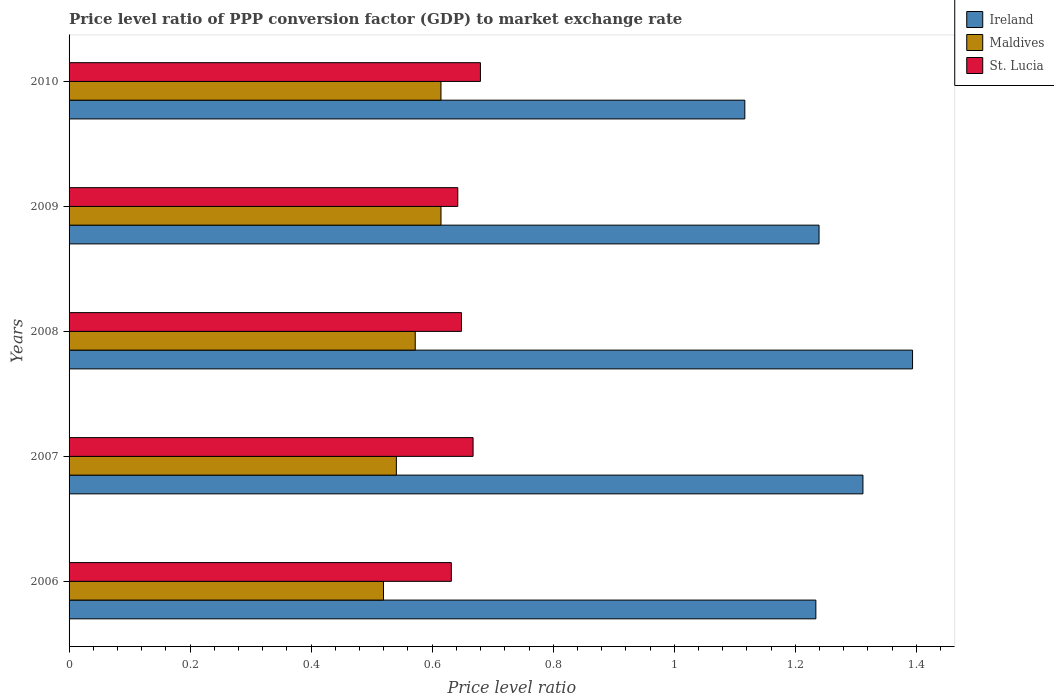How many groups of bars are there?
Provide a succinct answer. 5. Are the number of bars per tick equal to the number of legend labels?
Keep it short and to the point. Yes. How many bars are there on the 4th tick from the bottom?
Provide a short and direct response. 3. What is the label of the 2nd group of bars from the top?
Keep it short and to the point. 2009. In how many cases, is the number of bars for a given year not equal to the number of legend labels?
Your answer should be very brief. 0. What is the price level ratio in Maldives in 2007?
Provide a short and direct response. 0.54. Across all years, what is the maximum price level ratio in St. Lucia?
Give a very brief answer. 0.68. Across all years, what is the minimum price level ratio in Maldives?
Provide a succinct answer. 0.52. In which year was the price level ratio in St. Lucia minimum?
Offer a terse response. 2006. What is the total price level ratio in St. Lucia in the graph?
Ensure brevity in your answer.  3.27. What is the difference between the price level ratio in Ireland in 2006 and that in 2010?
Your answer should be compact. 0.12. What is the difference between the price level ratio in Ireland in 2009 and the price level ratio in St. Lucia in 2007?
Offer a terse response. 0.57. What is the average price level ratio in St. Lucia per year?
Your response must be concise. 0.65. In the year 2010, what is the difference between the price level ratio in Ireland and price level ratio in Maldives?
Your response must be concise. 0.5. What is the ratio of the price level ratio in Maldives in 2006 to that in 2007?
Keep it short and to the point. 0.96. Is the price level ratio in Maldives in 2007 less than that in 2008?
Offer a very short reply. Yes. What is the difference between the highest and the second highest price level ratio in Maldives?
Provide a succinct answer. 3.58968718040531e-5. What is the difference between the highest and the lowest price level ratio in Ireland?
Your answer should be very brief. 0.28. What does the 2nd bar from the top in 2007 represents?
Ensure brevity in your answer.  Maldives. What does the 2nd bar from the bottom in 2008 represents?
Offer a terse response. Maldives. Is it the case that in every year, the sum of the price level ratio in Ireland and price level ratio in St. Lucia is greater than the price level ratio in Maldives?
Your answer should be very brief. Yes. How many bars are there?
Provide a short and direct response. 15. Are all the bars in the graph horizontal?
Ensure brevity in your answer.  Yes. Does the graph contain any zero values?
Provide a succinct answer. No. Where does the legend appear in the graph?
Provide a short and direct response. Top right. How many legend labels are there?
Provide a succinct answer. 3. How are the legend labels stacked?
Provide a succinct answer. Vertical. What is the title of the graph?
Your answer should be very brief. Price level ratio of PPP conversion factor (GDP) to market exchange rate. Does "Fragile and conflict affected situations" appear as one of the legend labels in the graph?
Keep it short and to the point. No. What is the label or title of the X-axis?
Ensure brevity in your answer.  Price level ratio. What is the Price level ratio of Ireland in 2006?
Your answer should be compact. 1.23. What is the Price level ratio of Maldives in 2006?
Offer a very short reply. 0.52. What is the Price level ratio in St. Lucia in 2006?
Keep it short and to the point. 0.63. What is the Price level ratio in Ireland in 2007?
Offer a very short reply. 1.31. What is the Price level ratio in Maldives in 2007?
Give a very brief answer. 0.54. What is the Price level ratio in St. Lucia in 2007?
Make the answer very short. 0.67. What is the Price level ratio in Ireland in 2008?
Provide a succinct answer. 1.39. What is the Price level ratio of Maldives in 2008?
Offer a terse response. 0.57. What is the Price level ratio in St. Lucia in 2008?
Your response must be concise. 0.65. What is the Price level ratio of Ireland in 2009?
Your response must be concise. 1.24. What is the Price level ratio in Maldives in 2009?
Ensure brevity in your answer.  0.61. What is the Price level ratio in St. Lucia in 2009?
Your answer should be very brief. 0.64. What is the Price level ratio in Ireland in 2010?
Offer a terse response. 1.12. What is the Price level ratio in Maldives in 2010?
Provide a succinct answer. 0.61. What is the Price level ratio in St. Lucia in 2010?
Offer a terse response. 0.68. Across all years, what is the maximum Price level ratio of Ireland?
Your response must be concise. 1.39. Across all years, what is the maximum Price level ratio in Maldives?
Keep it short and to the point. 0.61. Across all years, what is the maximum Price level ratio of St. Lucia?
Keep it short and to the point. 0.68. Across all years, what is the minimum Price level ratio in Ireland?
Your answer should be very brief. 1.12. Across all years, what is the minimum Price level ratio in Maldives?
Your answer should be very brief. 0.52. Across all years, what is the minimum Price level ratio in St. Lucia?
Make the answer very short. 0.63. What is the total Price level ratio in Ireland in the graph?
Your answer should be very brief. 6.3. What is the total Price level ratio in Maldives in the graph?
Your answer should be very brief. 2.86. What is the total Price level ratio of St. Lucia in the graph?
Your answer should be very brief. 3.27. What is the difference between the Price level ratio in Ireland in 2006 and that in 2007?
Your answer should be very brief. -0.08. What is the difference between the Price level ratio of Maldives in 2006 and that in 2007?
Your answer should be very brief. -0.02. What is the difference between the Price level ratio of St. Lucia in 2006 and that in 2007?
Provide a short and direct response. -0.04. What is the difference between the Price level ratio in Ireland in 2006 and that in 2008?
Ensure brevity in your answer.  -0.16. What is the difference between the Price level ratio in Maldives in 2006 and that in 2008?
Give a very brief answer. -0.05. What is the difference between the Price level ratio of St. Lucia in 2006 and that in 2008?
Give a very brief answer. -0.02. What is the difference between the Price level ratio in Ireland in 2006 and that in 2009?
Offer a very short reply. -0.01. What is the difference between the Price level ratio of Maldives in 2006 and that in 2009?
Offer a very short reply. -0.1. What is the difference between the Price level ratio in St. Lucia in 2006 and that in 2009?
Provide a short and direct response. -0.01. What is the difference between the Price level ratio in Ireland in 2006 and that in 2010?
Offer a terse response. 0.12. What is the difference between the Price level ratio of Maldives in 2006 and that in 2010?
Offer a terse response. -0.1. What is the difference between the Price level ratio in St. Lucia in 2006 and that in 2010?
Make the answer very short. -0.05. What is the difference between the Price level ratio in Ireland in 2007 and that in 2008?
Offer a terse response. -0.08. What is the difference between the Price level ratio in Maldives in 2007 and that in 2008?
Your answer should be very brief. -0.03. What is the difference between the Price level ratio in St. Lucia in 2007 and that in 2008?
Your answer should be very brief. 0.02. What is the difference between the Price level ratio in Ireland in 2007 and that in 2009?
Give a very brief answer. 0.07. What is the difference between the Price level ratio in Maldives in 2007 and that in 2009?
Provide a short and direct response. -0.07. What is the difference between the Price level ratio of St. Lucia in 2007 and that in 2009?
Keep it short and to the point. 0.03. What is the difference between the Price level ratio of Ireland in 2007 and that in 2010?
Provide a succinct answer. 0.2. What is the difference between the Price level ratio in Maldives in 2007 and that in 2010?
Give a very brief answer. -0.07. What is the difference between the Price level ratio in St. Lucia in 2007 and that in 2010?
Provide a short and direct response. -0.01. What is the difference between the Price level ratio in Ireland in 2008 and that in 2009?
Your response must be concise. 0.15. What is the difference between the Price level ratio in Maldives in 2008 and that in 2009?
Give a very brief answer. -0.04. What is the difference between the Price level ratio in St. Lucia in 2008 and that in 2009?
Your response must be concise. 0.01. What is the difference between the Price level ratio of Ireland in 2008 and that in 2010?
Provide a succinct answer. 0.28. What is the difference between the Price level ratio in Maldives in 2008 and that in 2010?
Offer a very short reply. -0.04. What is the difference between the Price level ratio of St. Lucia in 2008 and that in 2010?
Your answer should be compact. -0.03. What is the difference between the Price level ratio of Ireland in 2009 and that in 2010?
Give a very brief answer. 0.12. What is the difference between the Price level ratio of Maldives in 2009 and that in 2010?
Your response must be concise. 0. What is the difference between the Price level ratio in St. Lucia in 2009 and that in 2010?
Keep it short and to the point. -0.04. What is the difference between the Price level ratio of Ireland in 2006 and the Price level ratio of Maldives in 2007?
Offer a terse response. 0.69. What is the difference between the Price level ratio in Ireland in 2006 and the Price level ratio in St. Lucia in 2007?
Your answer should be very brief. 0.57. What is the difference between the Price level ratio of Maldives in 2006 and the Price level ratio of St. Lucia in 2007?
Ensure brevity in your answer.  -0.15. What is the difference between the Price level ratio in Ireland in 2006 and the Price level ratio in Maldives in 2008?
Provide a short and direct response. 0.66. What is the difference between the Price level ratio in Ireland in 2006 and the Price level ratio in St. Lucia in 2008?
Provide a succinct answer. 0.59. What is the difference between the Price level ratio of Maldives in 2006 and the Price level ratio of St. Lucia in 2008?
Provide a short and direct response. -0.13. What is the difference between the Price level ratio of Ireland in 2006 and the Price level ratio of Maldives in 2009?
Give a very brief answer. 0.62. What is the difference between the Price level ratio in Ireland in 2006 and the Price level ratio in St. Lucia in 2009?
Your response must be concise. 0.59. What is the difference between the Price level ratio in Maldives in 2006 and the Price level ratio in St. Lucia in 2009?
Your answer should be compact. -0.12. What is the difference between the Price level ratio in Ireland in 2006 and the Price level ratio in Maldives in 2010?
Your answer should be very brief. 0.62. What is the difference between the Price level ratio in Ireland in 2006 and the Price level ratio in St. Lucia in 2010?
Your response must be concise. 0.55. What is the difference between the Price level ratio in Maldives in 2006 and the Price level ratio in St. Lucia in 2010?
Your response must be concise. -0.16. What is the difference between the Price level ratio in Ireland in 2007 and the Price level ratio in Maldives in 2008?
Provide a succinct answer. 0.74. What is the difference between the Price level ratio of Ireland in 2007 and the Price level ratio of St. Lucia in 2008?
Give a very brief answer. 0.66. What is the difference between the Price level ratio of Maldives in 2007 and the Price level ratio of St. Lucia in 2008?
Ensure brevity in your answer.  -0.11. What is the difference between the Price level ratio of Ireland in 2007 and the Price level ratio of Maldives in 2009?
Your answer should be very brief. 0.7. What is the difference between the Price level ratio in Ireland in 2007 and the Price level ratio in St. Lucia in 2009?
Provide a short and direct response. 0.67. What is the difference between the Price level ratio in Maldives in 2007 and the Price level ratio in St. Lucia in 2009?
Your answer should be very brief. -0.1. What is the difference between the Price level ratio in Ireland in 2007 and the Price level ratio in Maldives in 2010?
Make the answer very short. 0.7. What is the difference between the Price level ratio of Ireland in 2007 and the Price level ratio of St. Lucia in 2010?
Offer a very short reply. 0.63. What is the difference between the Price level ratio in Maldives in 2007 and the Price level ratio in St. Lucia in 2010?
Your response must be concise. -0.14. What is the difference between the Price level ratio in Ireland in 2008 and the Price level ratio in Maldives in 2009?
Provide a succinct answer. 0.78. What is the difference between the Price level ratio of Ireland in 2008 and the Price level ratio of St. Lucia in 2009?
Your answer should be compact. 0.75. What is the difference between the Price level ratio of Maldives in 2008 and the Price level ratio of St. Lucia in 2009?
Give a very brief answer. -0.07. What is the difference between the Price level ratio in Ireland in 2008 and the Price level ratio in Maldives in 2010?
Ensure brevity in your answer.  0.78. What is the difference between the Price level ratio of Ireland in 2008 and the Price level ratio of St. Lucia in 2010?
Provide a succinct answer. 0.71. What is the difference between the Price level ratio in Maldives in 2008 and the Price level ratio in St. Lucia in 2010?
Your answer should be very brief. -0.11. What is the difference between the Price level ratio in Ireland in 2009 and the Price level ratio in Maldives in 2010?
Provide a short and direct response. 0.62. What is the difference between the Price level ratio of Ireland in 2009 and the Price level ratio of St. Lucia in 2010?
Your answer should be compact. 0.56. What is the difference between the Price level ratio in Maldives in 2009 and the Price level ratio in St. Lucia in 2010?
Provide a succinct answer. -0.07. What is the average Price level ratio of Ireland per year?
Offer a terse response. 1.26. What is the average Price level ratio in Maldives per year?
Your answer should be compact. 0.57. What is the average Price level ratio in St. Lucia per year?
Keep it short and to the point. 0.65. In the year 2006, what is the difference between the Price level ratio of Ireland and Price level ratio of Maldives?
Provide a succinct answer. 0.71. In the year 2006, what is the difference between the Price level ratio in Ireland and Price level ratio in St. Lucia?
Offer a terse response. 0.6. In the year 2006, what is the difference between the Price level ratio in Maldives and Price level ratio in St. Lucia?
Ensure brevity in your answer.  -0.11. In the year 2007, what is the difference between the Price level ratio in Ireland and Price level ratio in Maldives?
Provide a succinct answer. 0.77. In the year 2007, what is the difference between the Price level ratio of Ireland and Price level ratio of St. Lucia?
Give a very brief answer. 0.64. In the year 2007, what is the difference between the Price level ratio in Maldives and Price level ratio in St. Lucia?
Keep it short and to the point. -0.13. In the year 2008, what is the difference between the Price level ratio in Ireland and Price level ratio in Maldives?
Ensure brevity in your answer.  0.82. In the year 2008, what is the difference between the Price level ratio in Ireland and Price level ratio in St. Lucia?
Make the answer very short. 0.75. In the year 2008, what is the difference between the Price level ratio in Maldives and Price level ratio in St. Lucia?
Make the answer very short. -0.08. In the year 2009, what is the difference between the Price level ratio of Ireland and Price level ratio of Maldives?
Give a very brief answer. 0.62. In the year 2009, what is the difference between the Price level ratio of Ireland and Price level ratio of St. Lucia?
Keep it short and to the point. 0.6. In the year 2009, what is the difference between the Price level ratio in Maldives and Price level ratio in St. Lucia?
Offer a very short reply. -0.03. In the year 2010, what is the difference between the Price level ratio in Ireland and Price level ratio in Maldives?
Ensure brevity in your answer.  0.5. In the year 2010, what is the difference between the Price level ratio in Ireland and Price level ratio in St. Lucia?
Your response must be concise. 0.44. In the year 2010, what is the difference between the Price level ratio in Maldives and Price level ratio in St. Lucia?
Provide a succinct answer. -0.07. What is the ratio of the Price level ratio of Ireland in 2006 to that in 2007?
Ensure brevity in your answer.  0.94. What is the ratio of the Price level ratio of Maldives in 2006 to that in 2007?
Ensure brevity in your answer.  0.96. What is the ratio of the Price level ratio in St. Lucia in 2006 to that in 2007?
Provide a succinct answer. 0.95. What is the ratio of the Price level ratio of Ireland in 2006 to that in 2008?
Your answer should be compact. 0.89. What is the ratio of the Price level ratio in Maldives in 2006 to that in 2008?
Provide a succinct answer. 0.91. What is the ratio of the Price level ratio in St. Lucia in 2006 to that in 2008?
Give a very brief answer. 0.97. What is the ratio of the Price level ratio of Maldives in 2006 to that in 2009?
Provide a succinct answer. 0.85. What is the ratio of the Price level ratio of St. Lucia in 2006 to that in 2009?
Give a very brief answer. 0.98. What is the ratio of the Price level ratio of Ireland in 2006 to that in 2010?
Ensure brevity in your answer.  1.11. What is the ratio of the Price level ratio in Maldives in 2006 to that in 2010?
Keep it short and to the point. 0.85. What is the ratio of the Price level ratio in St. Lucia in 2006 to that in 2010?
Make the answer very short. 0.93. What is the ratio of the Price level ratio in Maldives in 2007 to that in 2008?
Provide a short and direct response. 0.95. What is the ratio of the Price level ratio of St. Lucia in 2007 to that in 2008?
Make the answer very short. 1.03. What is the ratio of the Price level ratio in Ireland in 2007 to that in 2009?
Make the answer very short. 1.06. What is the ratio of the Price level ratio in Maldives in 2007 to that in 2009?
Offer a terse response. 0.88. What is the ratio of the Price level ratio in St. Lucia in 2007 to that in 2009?
Provide a succinct answer. 1.04. What is the ratio of the Price level ratio in Ireland in 2007 to that in 2010?
Offer a terse response. 1.17. What is the ratio of the Price level ratio in Maldives in 2007 to that in 2010?
Ensure brevity in your answer.  0.88. What is the ratio of the Price level ratio in St. Lucia in 2007 to that in 2010?
Give a very brief answer. 0.98. What is the ratio of the Price level ratio in Ireland in 2008 to that in 2009?
Offer a very short reply. 1.12. What is the ratio of the Price level ratio in Maldives in 2008 to that in 2009?
Keep it short and to the point. 0.93. What is the ratio of the Price level ratio in St. Lucia in 2008 to that in 2009?
Ensure brevity in your answer.  1.01. What is the ratio of the Price level ratio in Ireland in 2008 to that in 2010?
Provide a succinct answer. 1.25. What is the ratio of the Price level ratio in Maldives in 2008 to that in 2010?
Make the answer very short. 0.93. What is the ratio of the Price level ratio in St. Lucia in 2008 to that in 2010?
Ensure brevity in your answer.  0.95. What is the ratio of the Price level ratio of Ireland in 2009 to that in 2010?
Your answer should be very brief. 1.11. What is the ratio of the Price level ratio in St. Lucia in 2009 to that in 2010?
Keep it short and to the point. 0.94. What is the difference between the highest and the second highest Price level ratio of Ireland?
Offer a terse response. 0.08. What is the difference between the highest and the second highest Price level ratio of Maldives?
Offer a very short reply. 0. What is the difference between the highest and the second highest Price level ratio of St. Lucia?
Provide a succinct answer. 0.01. What is the difference between the highest and the lowest Price level ratio in Ireland?
Offer a terse response. 0.28. What is the difference between the highest and the lowest Price level ratio in Maldives?
Your response must be concise. 0.1. What is the difference between the highest and the lowest Price level ratio in St. Lucia?
Give a very brief answer. 0.05. 